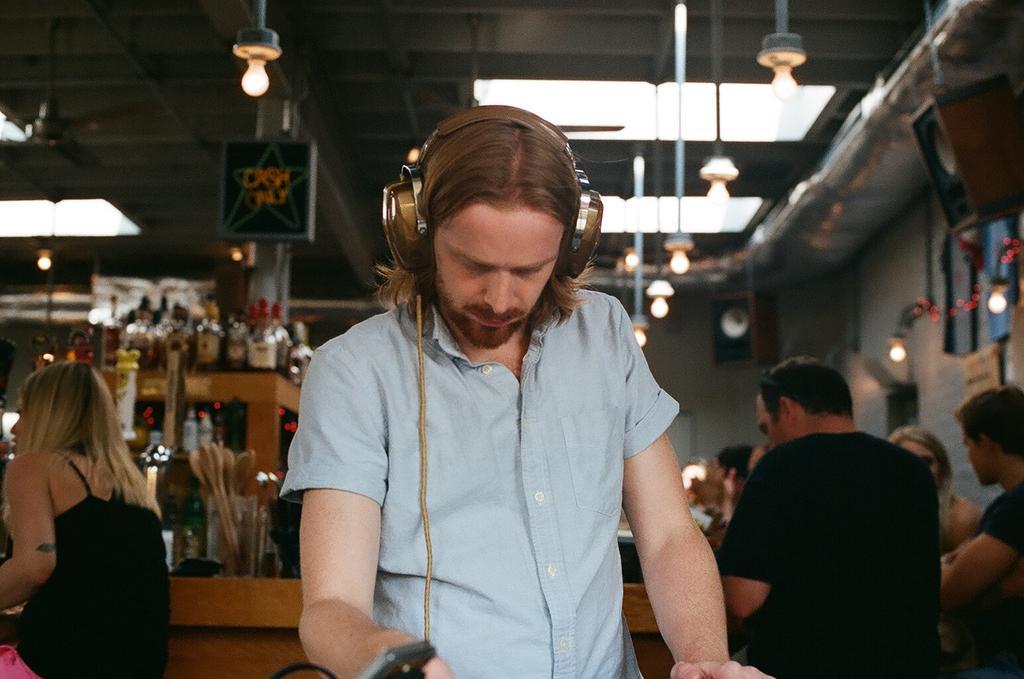In one or two sentences, can you explain what this image depicts? In this image in the front there is a man standing and wearing headphone. In the background there are persons sitting and there are bottles, there are lights hanging, there is a board with some text written on it and there is a table and on the table there are objects. 